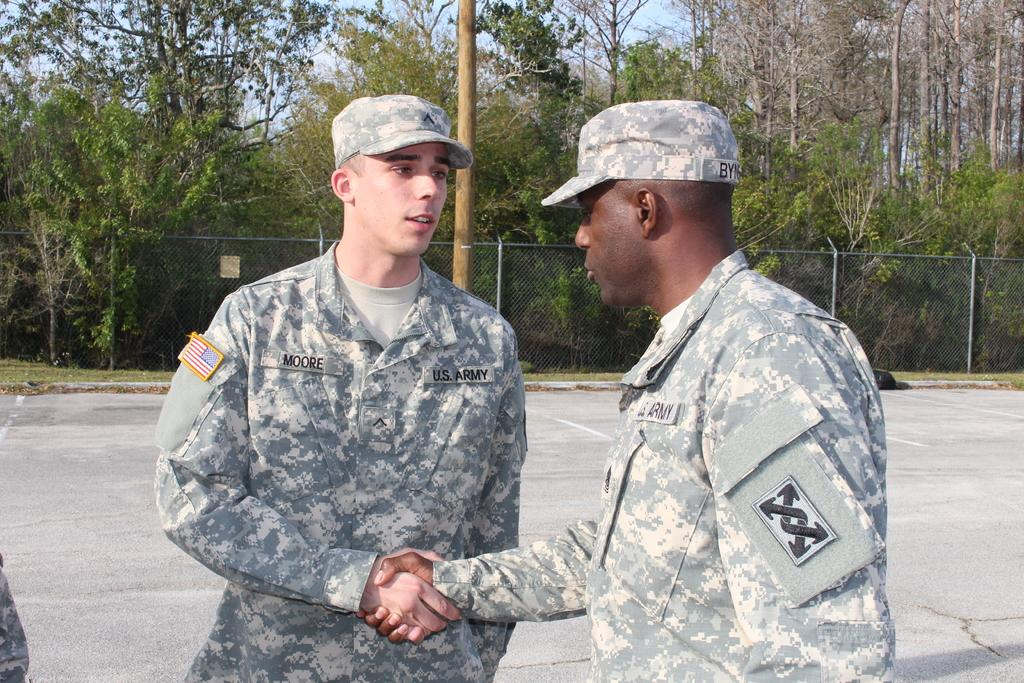How many people are in the image? There are two men in the image. What can be seen in the background of the image? There is ground, a fence, trees, and the sky visible in the background of the image. What type of impulse can be seen affecting the behavior of the men in the image? There is no indication of any impulse affecting the behavior of the men in the image. 